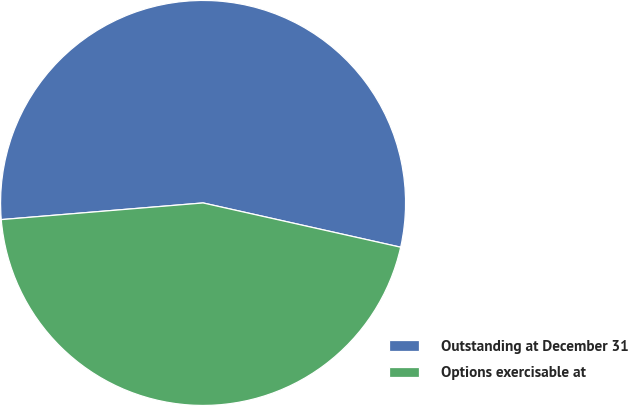Convert chart. <chart><loc_0><loc_0><loc_500><loc_500><pie_chart><fcel>Outstanding at December 31<fcel>Options exercisable at<nl><fcel>54.82%<fcel>45.18%<nl></chart> 